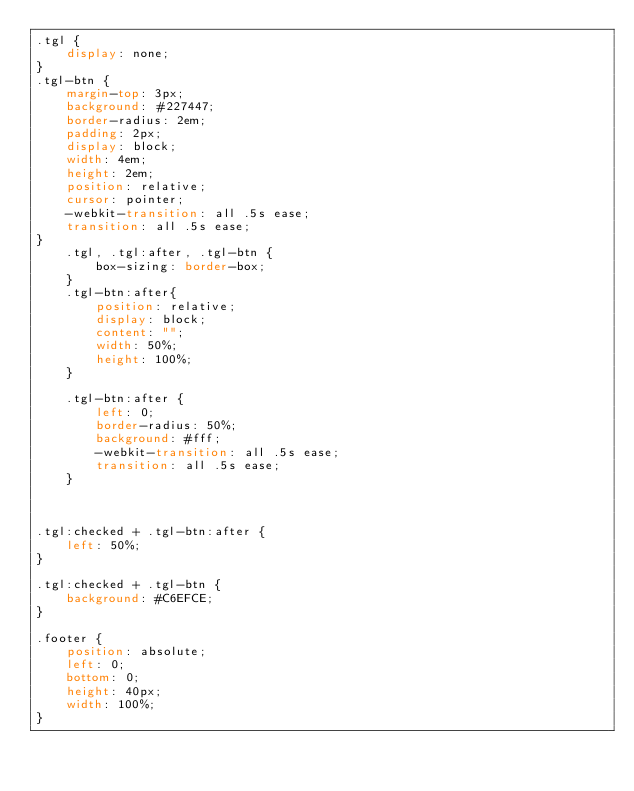<code> <loc_0><loc_0><loc_500><loc_500><_CSS_>.tgl {
    display: none;
}
.tgl-btn {
    margin-top: 3px;
    background: #227447;
    border-radius: 2em;
    padding: 2px;
    display: block;
    width: 4em;
    height: 2em;
    position: relative;
    cursor: pointer;
    -webkit-transition: all .5s ease;
    transition: all .5s ease;
}
    .tgl, .tgl:after, .tgl-btn {
        box-sizing: border-box;
    }
    .tgl-btn:after{
        position: relative;
        display: block;
        content: "";
        width: 50%;
        height: 100%;
    }

    .tgl-btn:after {
        left: 0;
        border-radius: 50%;
        background: #fff;
        -webkit-transition: all .5s ease;
        transition: all .5s ease;
    }



.tgl:checked + .tgl-btn:after {
    left: 50%;
}

.tgl:checked + .tgl-btn {
    background: #C6EFCE;
}

.footer {
    position: absolute;
    left: 0;
    bottom: 0;
    height: 40px;
    width: 100%;
}
</code> 